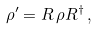Convert formula to latex. <formula><loc_0><loc_0><loc_500><loc_500>\rho ^ { \prime } = { R } \, \rho { R } ^ { \dagger } \, ,</formula> 